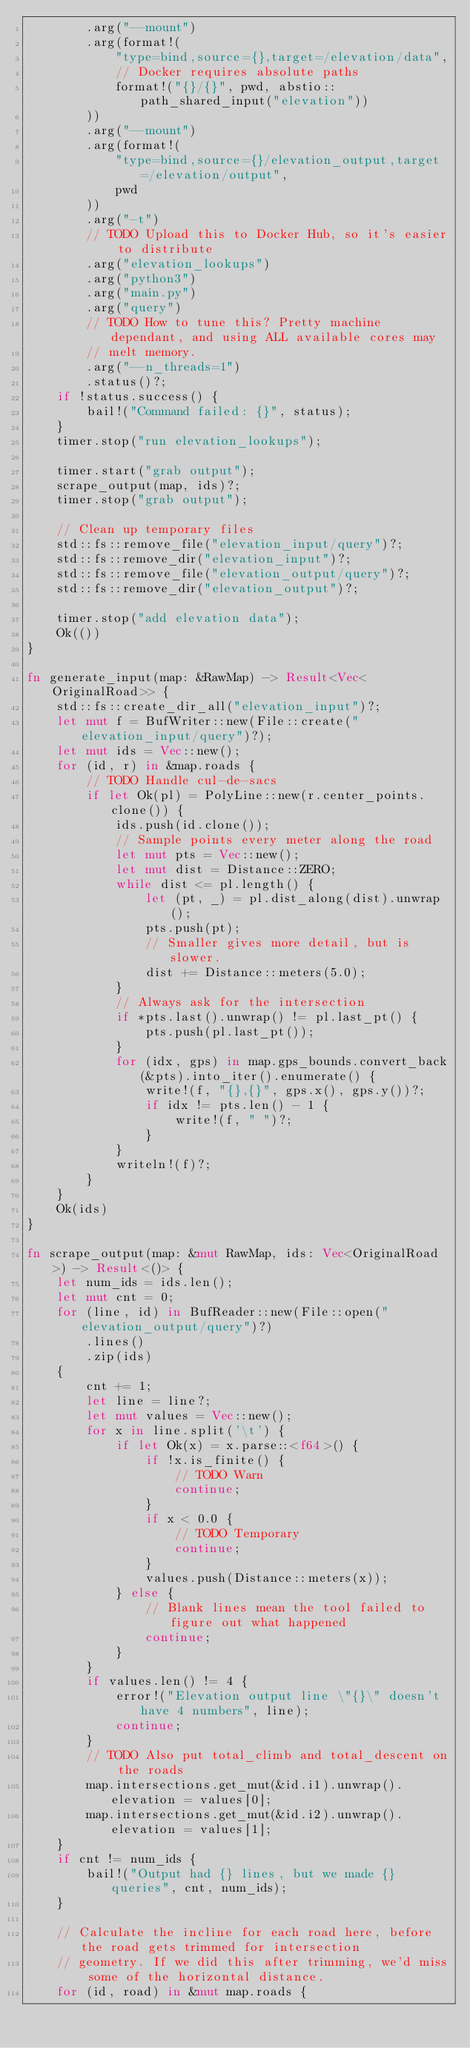<code> <loc_0><loc_0><loc_500><loc_500><_Rust_>        .arg("--mount")
        .arg(format!(
            "type=bind,source={},target=/elevation/data",
            // Docker requires absolute paths
            format!("{}/{}", pwd, abstio::path_shared_input("elevation"))
        ))
        .arg("--mount")
        .arg(format!(
            "type=bind,source={}/elevation_output,target=/elevation/output",
            pwd
        ))
        .arg("-t")
        // TODO Upload this to Docker Hub, so it's easier to distribute
        .arg("elevation_lookups")
        .arg("python3")
        .arg("main.py")
        .arg("query")
        // TODO How to tune this? Pretty machine dependant, and using ALL available cores may
        // melt memory.
        .arg("--n_threads=1")
        .status()?;
    if !status.success() {
        bail!("Command failed: {}", status);
    }
    timer.stop("run elevation_lookups");

    timer.start("grab output");
    scrape_output(map, ids)?;
    timer.stop("grab output");

    // Clean up temporary files
    std::fs::remove_file("elevation_input/query")?;
    std::fs::remove_dir("elevation_input")?;
    std::fs::remove_file("elevation_output/query")?;
    std::fs::remove_dir("elevation_output")?;

    timer.stop("add elevation data");
    Ok(())
}

fn generate_input(map: &RawMap) -> Result<Vec<OriginalRoad>> {
    std::fs::create_dir_all("elevation_input")?;
    let mut f = BufWriter::new(File::create("elevation_input/query")?);
    let mut ids = Vec::new();
    for (id, r) in &map.roads {
        // TODO Handle cul-de-sacs
        if let Ok(pl) = PolyLine::new(r.center_points.clone()) {
            ids.push(id.clone());
            // Sample points every meter along the road
            let mut pts = Vec::new();
            let mut dist = Distance::ZERO;
            while dist <= pl.length() {
                let (pt, _) = pl.dist_along(dist).unwrap();
                pts.push(pt);
                // Smaller gives more detail, but is slower.
                dist += Distance::meters(5.0);
            }
            // Always ask for the intersection
            if *pts.last().unwrap() != pl.last_pt() {
                pts.push(pl.last_pt());
            }
            for (idx, gps) in map.gps_bounds.convert_back(&pts).into_iter().enumerate() {
                write!(f, "{},{}", gps.x(), gps.y())?;
                if idx != pts.len() - 1 {
                    write!(f, " ")?;
                }
            }
            writeln!(f)?;
        }
    }
    Ok(ids)
}

fn scrape_output(map: &mut RawMap, ids: Vec<OriginalRoad>) -> Result<()> {
    let num_ids = ids.len();
    let mut cnt = 0;
    for (line, id) in BufReader::new(File::open("elevation_output/query")?)
        .lines()
        .zip(ids)
    {
        cnt += 1;
        let line = line?;
        let mut values = Vec::new();
        for x in line.split('\t') {
            if let Ok(x) = x.parse::<f64>() {
                if !x.is_finite() {
                    // TODO Warn
                    continue;
                }
                if x < 0.0 {
                    // TODO Temporary
                    continue;
                }
                values.push(Distance::meters(x));
            } else {
                // Blank lines mean the tool failed to figure out what happened
                continue;
            }
        }
        if values.len() != 4 {
            error!("Elevation output line \"{}\" doesn't have 4 numbers", line);
            continue;
        }
        // TODO Also put total_climb and total_descent on the roads
        map.intersections.get_mut(&id.i1).unwrap().elevation = values[0];
        map.intersections.get_mut(&id.i2).unwrap().elevation = values[1];
    }
    if cnt != num_ids {
        bail!("Output had {} lines, but we made {} queries", cnt, num_ids);
    }

    // Calculate the incline for each road here, before the road gets trimmed for intersection
    // geometry. If we did this after trimming, we'd miss some of the horizontal distance.
    for (id, road) in &mut map.roads {</code> 